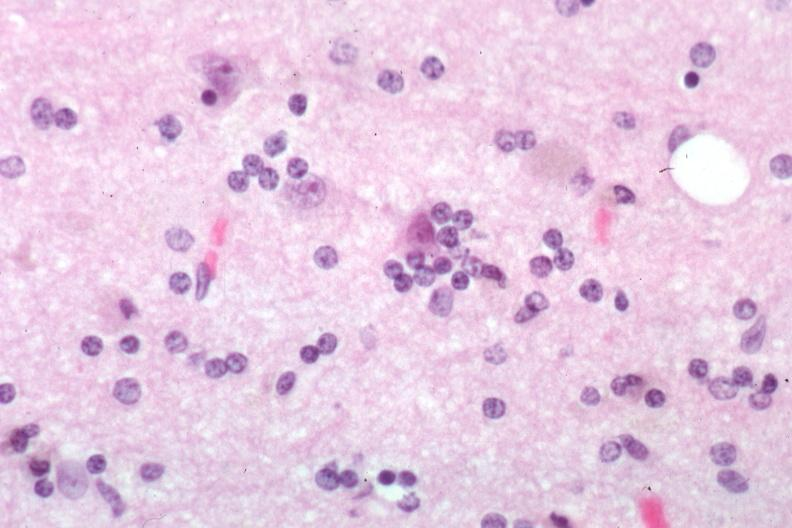what is present?
Answer the question using a single word or phrase. Brain 